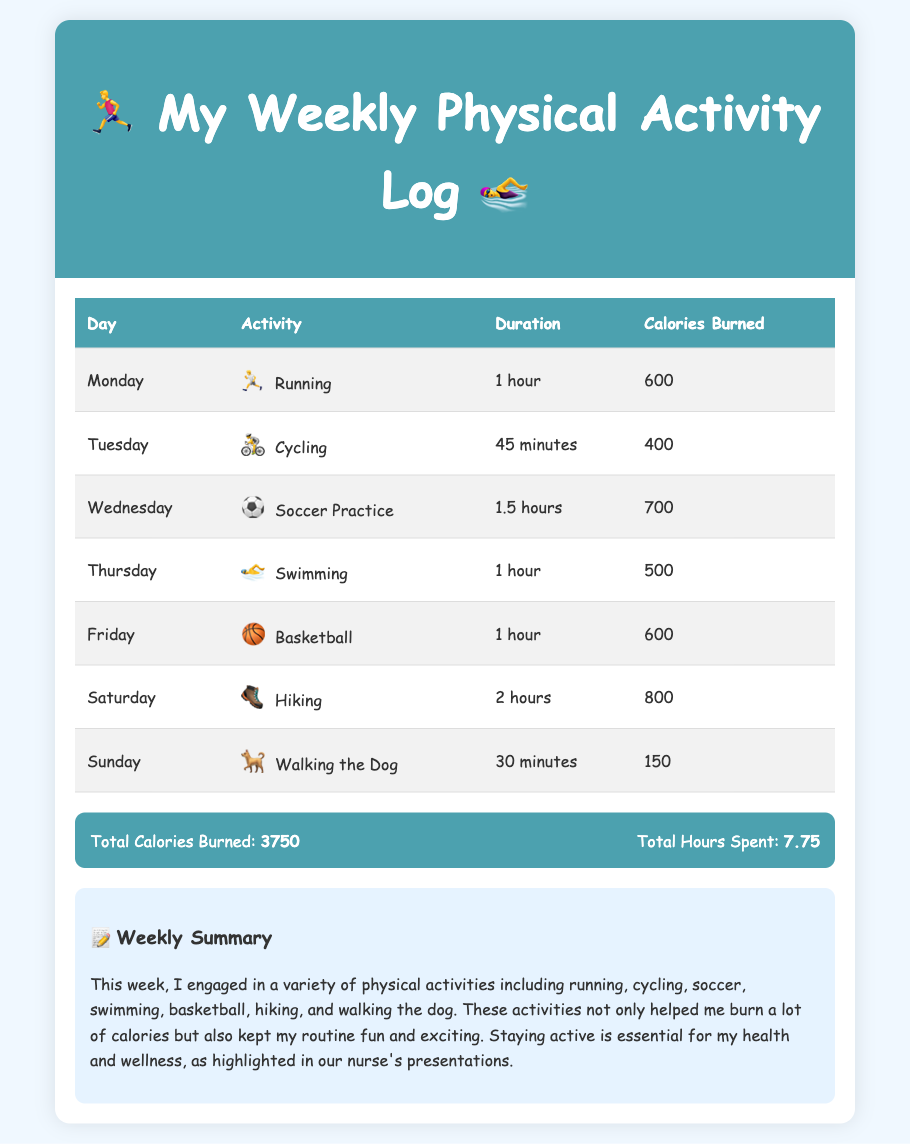What is the total calories burned for the week? The total calories burned for the week is the sum of calories burned each day, which is 600 + 400 + 700 + 500 + 600 + 800 + 150 = 3750.
Answer: 3750 How many hours did I spend on physical activities? The total hours spent on physical activities is the sum of hours spent each day, which is 1 + 0.75 + 1.5 + 1 + 1 + 2 + 0.5 = 7.75.
Answer: 7.75 Which activity burned the most calories? The activity that burned the most calories is determined by comparing the calories burned for each activity, which shows that hiking burned 800 calories.
Answer: Hiking What activity did I do on Wednesday? The activity performed on Wednesday is the one listed for that day, which is soccer practice.
Answer: Soccer Practice On which day did I walk the dog? The day for walking the dog is listed in the daily activities, which is Sunday.
Answer: Sunday How long did I spend cycling? The duration spent on cycling is mentioned in the table for that activity, which is 45 minutes.
Answer: 45 minutes What is the emoji for swimming? The emoji associated with swimming is specified next to the activity, which is 🏊‍♂️.
Answer: 🏊‍♂️ Which two activities took place for 1 hour? The activities that took 1 hour are identified by their durations in the table, which are running and swimming.
Answer: Running and Swimming 